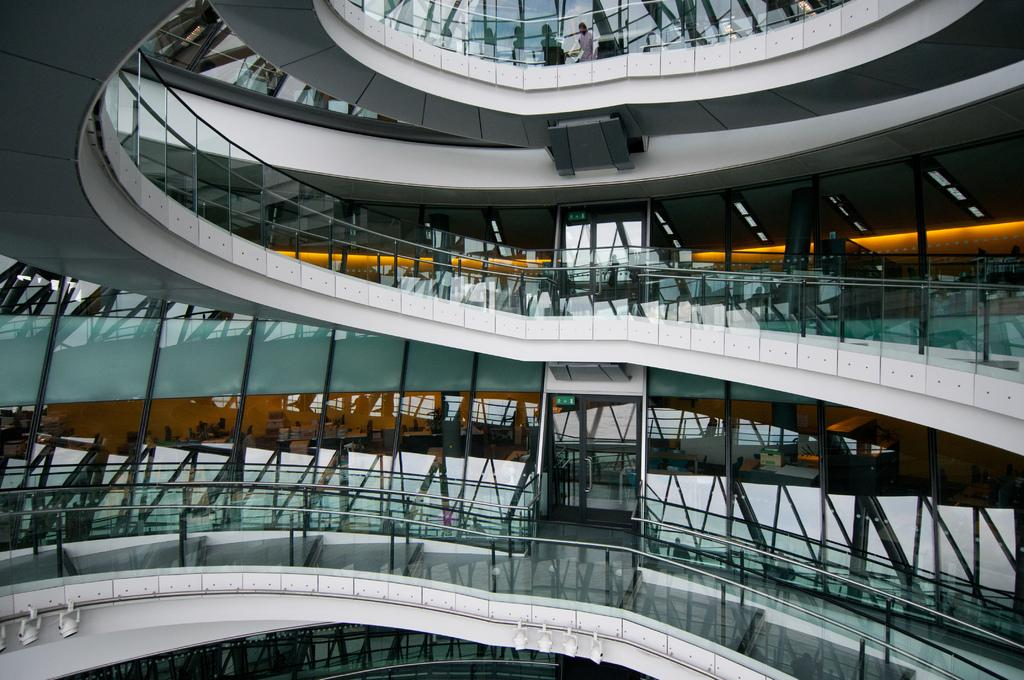What type of location is depicted in the image? The image shows an inside view of a building. What objects can be seen in the middle of the image? There are glasses and metal rods visible in the middle of the image. What can be seen in the background of the image? There are lights visible in the background of the image. What type of toothpaste is being used to clean the metal rods in the image? There is no toothpaste present in the image, and the metal rods are not being cleaned. --- Facts: 1. There is a person sitting on a chair in the image. 2. The person is holding a book. 3. There is a table next to the chair. 4. There is a lamp on the table. 5. The background of the image is a wall. Absurd Topics: parrot, sand, bicycle Conversation: What is the person in the image doing? The person is sitting on a chair in the image. What object is the person holding? The person is holding a book. What is located next to the chair? There is a table next to the chair. What is on the table? There is a lamp on the table. What can be seen behind the person? The background of the image is a wall. Reasoning: Let's think step by step in order to produce the conversation. We start by identifying the main subject in the image, which is the person sitting on a chair. Then, we expand the conversation to include the object the person is holding (a book) and the objects located near the chair (a table and a lamp). Finally, we describe the background of the image, which is a wall. Each question is designed to elicit a specific detail about the image that is known from the provided facts. Absurd Question/Answer: Can you see any sand or bicycles in the image? No, there is no sand or bicycles present in the image. 